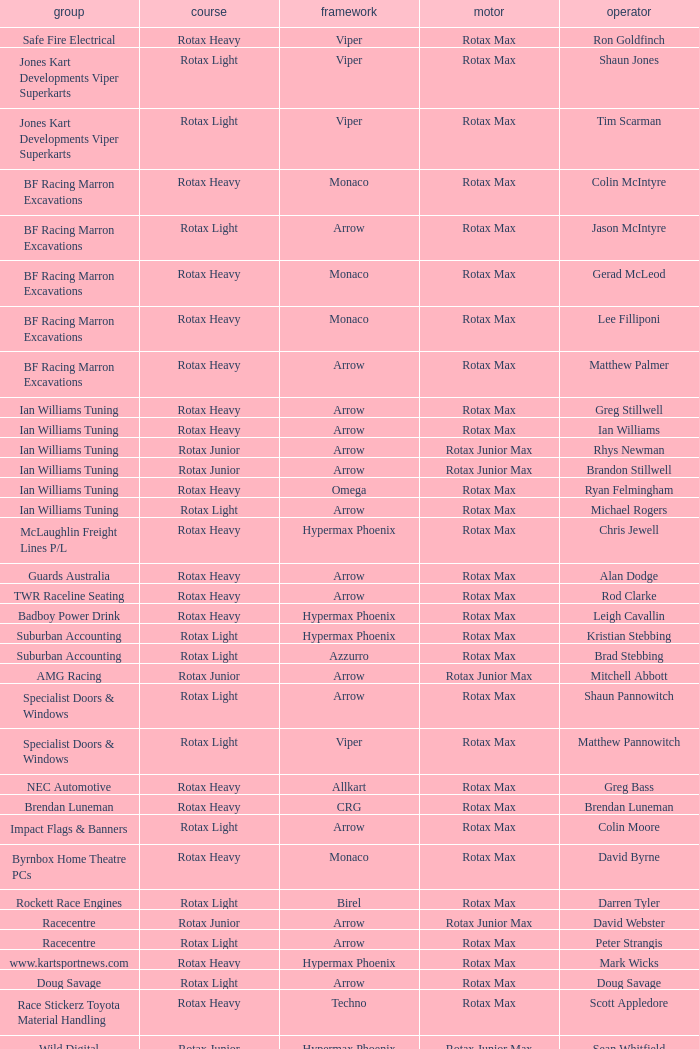Driver Shaun Jones with a viper as a chassis is in what class? Rotax Light. Could you help me parse every detail presented in this table? {'header': ['group', 'course', 'framework', 'motor', 'operator'], 'rows': [['Safe Fire Electrical', 'Rotax Heavy', 'Viper', 'Rotax Max', 'Ron Goldfinch'], ['Jones Kart Developments Viper Superkarts', 'Rotax Light', 'Viper', 'Rotax Max', 'Shaun Jones'], ['Jones Kart Developments Viper Superkarts', 'Rotax Light', 'Viper', 'Rotax Max', 'Tim Scarman'], ['BF Racing Marron Excavations', 'Rotax Heavy', 'Monaco', 'Rotax Max', 'Colin McIntyre'], ['BF Racing Marron Excavations', 'Rotax Light', 'Arrow', 'Rotax Max', 'Jason McIntyre'], ['BF Racing Marron Excavations', 'Rotax Heavy', 'Monaco', 'Rotax Max', 'Gerad McLeod'], ['BF Racing Marron Excavations', 'Rotax Heavy', 'Monaco', 'Rotax Max', 'Lee Filliponi'], ['BF Racing Marron Excavations', 'Rotax Heavy', 'Arrow', 'Rotax Max', 'Matthew Palmer'], ['Ian Williams Tuning', 'Rotax Heavy', 'Arrow', 'Rotax Max', 'Greg Stillwell'], ['Ian Williams Tuning', 'Rotax Heavy', 'Arrow', 'Rotax Max', 'Ian Williams'], ['Ian Williams Tuning', 'Rotax Junior', 'Arrow', 'Rotax Junior Max', 'Rhys Newman'], ['Ian Williams Tuning', 'Rotax Junior', 'Arrow', 'Rotax Junior Max', 'Brandon Stillwell'], ['Ian Williams Tuning', 'Rotax Heavy', 'Omega', 'Rotax Max', 'Ryan Felmingham'], ['Ian Williams Tuning', 'Rotax Light', 'Arrow', 'Rotax Max', 'Michael Rogers'], ['McLaughlin Freight Lines P/L', 'Rotax Heavy', 'Hypermax Phoenix', 'Rotax Max', 'Chris Jewell'], ['Guards Australia', 'Rotax Heavy', 'Arrow', 'Rotax Max', 'Alan Dodge'], ['TWR Raceline Seating', 'Rotax Heavy', 'Arrow', 'Rotax Max', 'Rod Clarke'], ['Badboy Power Drink', 'Rotax Heavy', 'Hypermax Phoenix', 'Rotax Max', 'Leigh Cavallin'], ['Suburban Accounting', 'Rotax Light', 'Hypermax Phoenix', 'Rotax Max', 'Kristian Stebbing'], ['Suburban Accounting', 'Rotax Light', 'Azzurro', 'Rotax Max', 'Brad Stebbing'], ['AMG Racing', 'Rotax Junior', 'Arrow', 'Rotax Junior Max', 'Mitchell Abbott'], ['Specialist Doors & Windows', 'Rotax Light', 'Arrow', 'Rotax Max', 'Shaun Pannowitch'], ['Specialist Doors & Windows', 'Rotax Light', 'Viper', 'Rotax Max', 'Matthew Pannowitch'], ['NEC Automotive', 'Rotax Heavy', 'Allkart', 'Rotax Max', 'Greg Bass'], ['Brendan Luneman', 'Rotax Heavy', 'CRG', 'Rotax Max', 'Brendan Luneman'], ['Impact Flags & Banners', 'Rotax Light', 'Arrow', 'Rotax Max', 'Colin Moore'], ['Byrnbox Home Theatre PCs', 'Rotax Heavy', 'Monaco', 'Rotax Max', 'David Byrne'], ['Rockett Race Engines', 'Rotax Light', 'Birel', 'Rotax Max', 'Darren Tyler'], ['Racecentre', 'Rotax Junior', 'Arrow', 'Rotax Junior Max', 'David Webster'], ['Racecentre', 'Rotax Light', 'Arrow', 'Rotax Max', 'Peter Strangis'], ['www.kartsportnews.com', 'Rotax Heavy', 'Hypermax Phoenix', 'Rotax Max', 'Mark Wicks'], ['Doug Savage', 'Rotax Light', 'Arrow', 'Rotax Max', 'Doug Savage'], ['Race Stickerz Toyota Material Handling', 'Rotax Heavy', 'Techno', 'Rotax Max', 'Scott Appledore'], ['Wild Digital', 'Rotax Junior', 'Hypermax Phoenix', 'Rotax Junior Max', 'Sean Whitfield'], ['John Bartlett', 'Rotax Heavy', 'Hypermax Phoenix', 'Rotax Max', 'John Bartlett']]} 